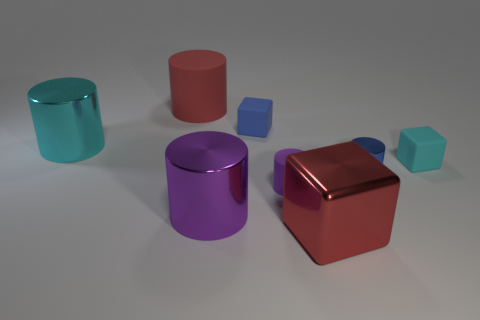Imagine these objects are part of a game, what sort of game could it be? If these objects were part of a game, it could be a puzzle game where the objective is to sort or stack the shapes according to specific rules, such as by color or size. Alternatively, it could be an educational game for children, aimed at teaching color and shape recognition by asking players to match or identify different objects. 